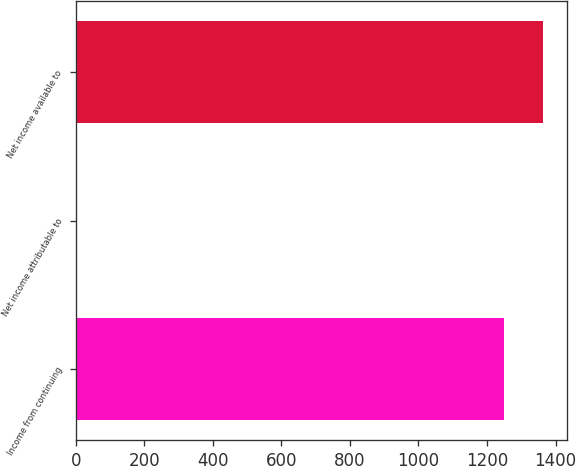<chart> <loc_0><loc_0><loc_500><loc_500><bar_chart><fcel>Income from continuing<fcel>Net income attributable to<fcel>Net income available to<nl><fcel>1250.6<fcel>2<fcel>1364.2<nl></chart> 